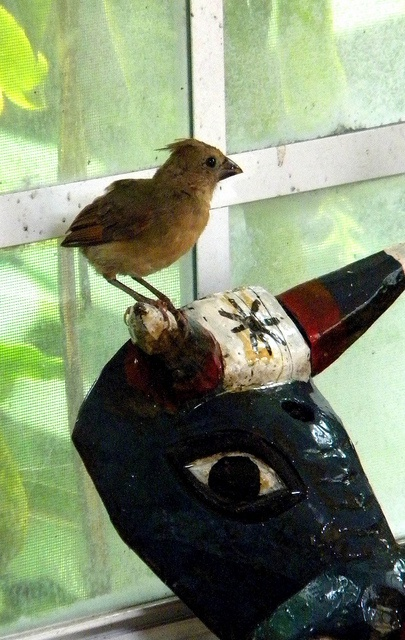Describe the objects in this image and their specific colors. I can see cow in olive, black, gray, beige, and maroon tones and bird in olive and black tones in this image. 